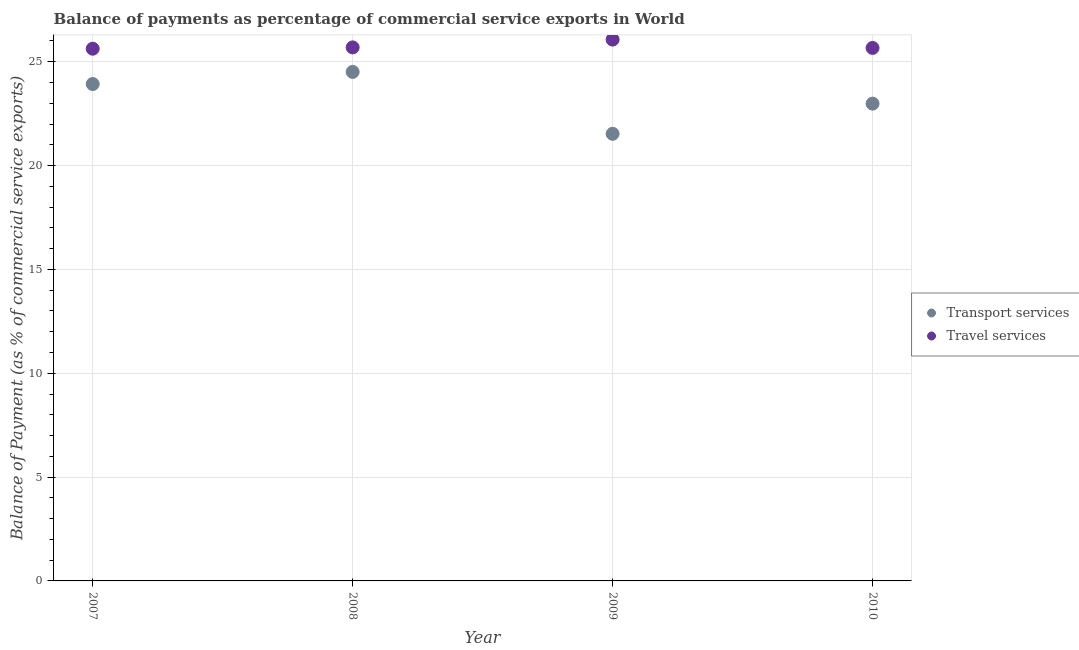How many different coloured dotlines are there?
Ensure brevity in your answer.  2. Is the number of dotlines equal to the number of legend labels?
Offer a very short reply. Yes. What is the balance of payments of transport services in 2008?
Your answer should be compact. 24.51. Across all years, what is the maximum balance of payments of travel services?
Offer a terse response. 26.07. Across all years, what is the minimum balance of payments of transport services?
Your answer should be very brief. 21.53. In which year was the balance of payments of travel services maximum?
Provide a succinct answer. 2009. In which year was the balance of payments of transport services minimum?
Ensure brevity in your answer.  2009. What is the total balance of payments of transport services in the graph?
Ensure brevity in your answer.  92.95. What is the difference between the balance of payments of travel services in 2007 and that in 2009?
Keep it short and to the point. -0.44. What is the difference between the balance of payments of transport services in 2007 and the balance of payments of travel services in 2010?
Offer a terse response. -1.74. What is the average balance of payments of travel services per year?
Provide a short and direct response. 25.76. In the year 2010, what is the difference between the balance of payments of transport services and balance of payments of travel services?
Your response must be concise. -2.68. What is the ratio of the balance of payments of travel services in 2007 to that in 2009?
Keep it short and to the point. 0.98. Is the difference between the balance of payments of travel services in 2009 and 2010 greater than the difference between the balance of payments of transport services in 2009 and 2010?
Provide a short and direct response. Yes. What is the difference between the highest and the second highest balance of payments of transport services?
Offer a very short reply. 0.58. What is the difference between the highest and the lowest balance of payments of transport services?
Your response must be concise. 2.98. In how many years, is the balance of payments of transport services greater than the average balance of payments of transport services taken over all years?
Provide a short and direct response. 2. Does the balance of payments of travel services monotonically increase over the years?
Offer a very short reply. No. Is the balance of payments of travel services strictly less than the balance of payments of transport services over the years?
Provide a succinct answer. No. How many dotlines are there?
Provide a succinct answer. 2. Are the values on the major ticks of Y-axis written in scientific E-notation?
Give a very brief answer. No. Does the graph contain any zero values?
Your answer should be compact. No. What is the title of the graph?
Give a very brief answer. Balance of payments as percentage of commercial service exports in World. What is the label or title of the Y-axis?
Keep it short and to the point. Balance of Payment (as % of commercial service exports). What is the Balance of Payment (as % of commercial service exports) in Transport services in 2007?
Offer a terse response. 23.93. What is the Balance of Payment (as % of commercial service exports) of Travel services in 2007?
Make the answer very short. 25.63. What is the Balance of Payment (as % of commercial service exports) of Transport services in 2008?
Offer a terse response. 24.51. What is the Balance of Payment (as % of commercial service exports) in Travel services in 2008?
Your response must be concise. 25.69. What is the Balance of Payment (as % of commercial service exports) of Transport services in 2009?
Ensure brevity in your answer.  21.53. What is the Balance of Payment (as % of commercial service exports) of Travel services in 2009?
Make the answer very short. 26.07. What is the Balance of Payment (as % of commercial service exports) of Transport services in 2010?
Ensure brevity in your answer.  22.98. What is the Balance of Payment (as % of commercial service exports) of Travel services in 2010?
Provide a succinct answer. 25.66. Across all years, what is the maximum Balance of Payment (as % of commercial service exports) in Transport services?
Offer a terse response. 24.51. Across all years, what is the maximum Balance of Payment (as % of commercial service exports) in Travel services?
Provide a succinct answer. 26.07. Across all years, what is the minimum Balance of Payment (as % of commercial service exports) of Transport services?
Make the answer very short. 21.53. Across all years, what is the minimum Balance of Payment (as % of commercial service exports) of Travel services?
Make the answer very short. 25.63. What is the total Balance of Payment (as % of commercial service exports) of Transport services in the graph?
Keep it short and to the point. 92.95. What is the total Balance of Payment (as % of commercial service exports) in Travel services in the graph?
Keep it short and to the point. 103.05. What is the difference between the Balance of Payment (as % of commercial service exports) of Transport services in 2007 and that in 2008?
Ensure brevity in your answer.  -0.58. What is the difference between the Balance of Payment (as % of commercial service exports) of Travel services in 2007 and that in 2008?
Your answer should be very brief. -0.06. What is the difference between the Balance of Payment (as % of commercial service exports) of Transport services in 2007 and that in 2009?
Provide a short and direct response. 2.4. What is the difference between the Balance of Payment (as % of commercial service exports) of Travel services in 2007 and that in 2009?
Offer a very short reply. -0.44. What is the difference between the Balance of Payment (as % of commercial service exports) of Transport services in 2007 and that in 2010?
Provide a short and direct response. 0.95. What is the difference between the Balance of Payment (as % of commercial service exports) of Travel services in 2007 and that in 2010?
Offer a very short reply. -0.04. What is the difference between the Balance of Payment (as % of commercial service exports) of Transport services in 2008 and that in 2009?
Your response must be concise. 2.98. What is the difference between the Balance of Payment (as % of commercial service exports) in Travel services in 2008 and that in 2009?
Make the answer very short. -0.38. What is the difference between the Balance of Payment (as % of commercial service exports) of Transport services in 2008 and that in 2010?
Your response must be concise. 1.53. What is the difference between the Balance of Payment (as % of commercial service exports) of Travel services in 2008 and that in 2010?
Your response must be concise. 0.03. What is the difference between the Balance of Payment (as % of commercial service exports) in Transport services in 2009 and that in 2010?
Your answer should be compact. -1.45. What is the difference between the Balance of Payment (as % of commercial service exports) in Travel services in 2009 and that in 2010?
Provide a short and direct response. 0.4. What is the difference between the Balance of Payment (as % of commercial service exports) in Transport services in 2007 and the Balance of Payment (as % of commercial service exports) in Travel services in 2008?
Offer a very short reply. -1.76. What is the difference between the Balance of Payment (as % of commercial service exports) in Transport services in 2007 and the Balance of Payment (as % of commercial service exports) in Travel services in 2009?
Your response must be concise. -2.14. What is the difference between the Balance of Payment (as % of commercial service exports) in Transport services in 2007 and the Balance of Payment (as % of commercial service exports) in Travel services in 2010?
Keep it short and to the point. -1.74. What is the difference between the Balance of Payment (as % of commercial service exports) of Transport services in 2008 and the Balance of Payment (as % of commercial service exports) of Travel services in 2009?
Make the answer very short. -1.56. What is the difference between the Balance of Payment (as % of commercial service exports) of Transport services in 2008 and the Balance of Payment (as % of commercial service exports) of Travel services in 2010?
Your answer should be very brief. -1.15. What is the difference between the Balance of Payment (as % of commercial service exports) in Transport services in 2009 and the Balance of Payment (as % of commercial service exports) in Travel services in 2010?
Make the answer very short. -4.13. What is the average Balance of Payment (as % of commercial service exports) of Transport services per year?
Keep it short and to the point. 23.24. What is the average Balance of Payment (as % of commercial service exports) in Travel services per year?
Offer a very short reply. 25.76. In the year 2007, what is the difference between the Balance of Payment (as % of commercial service exports) in Transport services and Balance of Payment (as % of commercial service exports) in Travel services?
Provide a short and direct response. -1.7. In the year 2008, what is the difference between the Balance of Payment (as % of commercial service exports) of Transport services and Balance of Payment (as % of commercial service exports) of Travel services?
Provide a succinct answer. -1.18. In the year 2009, what is the difference between the Balance of Payment (as % of commercial service exports) of Transport services and Balance of Payment (as % of commercial service exports) of Travel services?
Offer a very short reply. -4.54. In the year 2010, what is the difference between the Balance of Payment (as % of commercial service exports) in Transport services and Balance of Payment (as % of commercial service exports) in Travel services?
Provide a succinct answer. -2.68. What is the ratio of the Balance of Payment (as % of commercial service exports) in Transport services in 2007 to that in 2008?
Ensure brevity in your answer.  0.98. What is the ratio of the Balance of Payment (as % of commercial service exports) in Transport services in 2007 to that in 2009?
Give a very brief answer. 1.11. What is the ratio of the Balance of Payment (as % of commercial service exports) of Travel services in 2007 to that in 2009?
Provide a short and direct response. 0.98. What is the ratio of the Balance of Payment (as % of commercial service exports) of Transport services in 2007 to that in 2010?
Provide a succinct answer. 1.04. What is the ratio of the Balance of Payment (as % of commercial service exports) of Travel services in 2007 to that in 2010?
Your answer should be compact. 1. What is the ratio of the Balance of Payment (as % of commercial service exports) in Transport services in 2008 to that in 2009?
Offer a very short reply. 1.14. What is the ratio of the Balance of Payment (as % of commercial service exports) in Travel services in 2008 to that in 2009?
Offer a very short reply. 0.99. What is the ratio of the Balance of Payment (as % of commercial service exports) in Transport services in 2008 to that in 2010?
Ensure brevity in your answer.  1.07. What is the ratio of the Balance of Payment (as % of commercial service exports) of Transport services in 2009 to that in 2010?
Give a very brief answer. 0.94. What is the ratio of the Balance of Payment (as % of commercial service exports) in Travel services in 2009 to that in 2010?
Your answer should be very brief. 1.02. What is the difference between the highest and the second highest Balance of Payment (as % of commercial service exports) of Transport services?
Provide a short and direct response. 0.58. What is the difference between the highest and the second highest Balance of Payment (as % of commercial service exports) in Travel services?
Provide a short and direct response. 0.38. What is the difference between the highest and the lowest Balance of Payment (as % of commercial service exports) in Transport services?
Offer a very short reply. 2.98. What is the difference between the highest and the lowest Balance of Payment (as % of commercial service exports) of Travel services?
Keep it short and to the point. 0.44. 